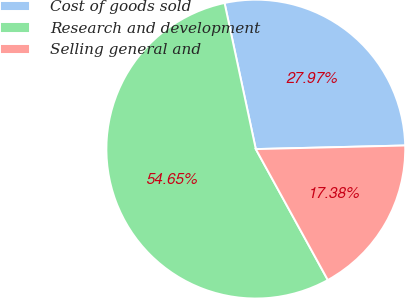<chart> <loc_0><loc_0><loc_500><loc_500><pie_chart><fcel>Cost of goods sold<fcel>Research and development<fcel>Selling general and<nl><fcel>27.97%<fcel>54.65%<fcel>17.38%<nl></chart> 